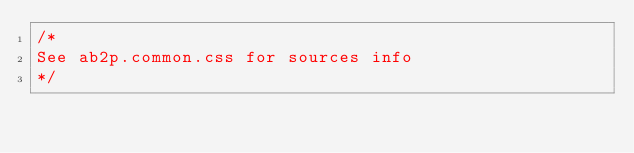Convert code to text. <code><loc_0><loc_0><loc_500><loc_500><_CSS_>/*
See ab2p.common.css for sources info
*/</code> 